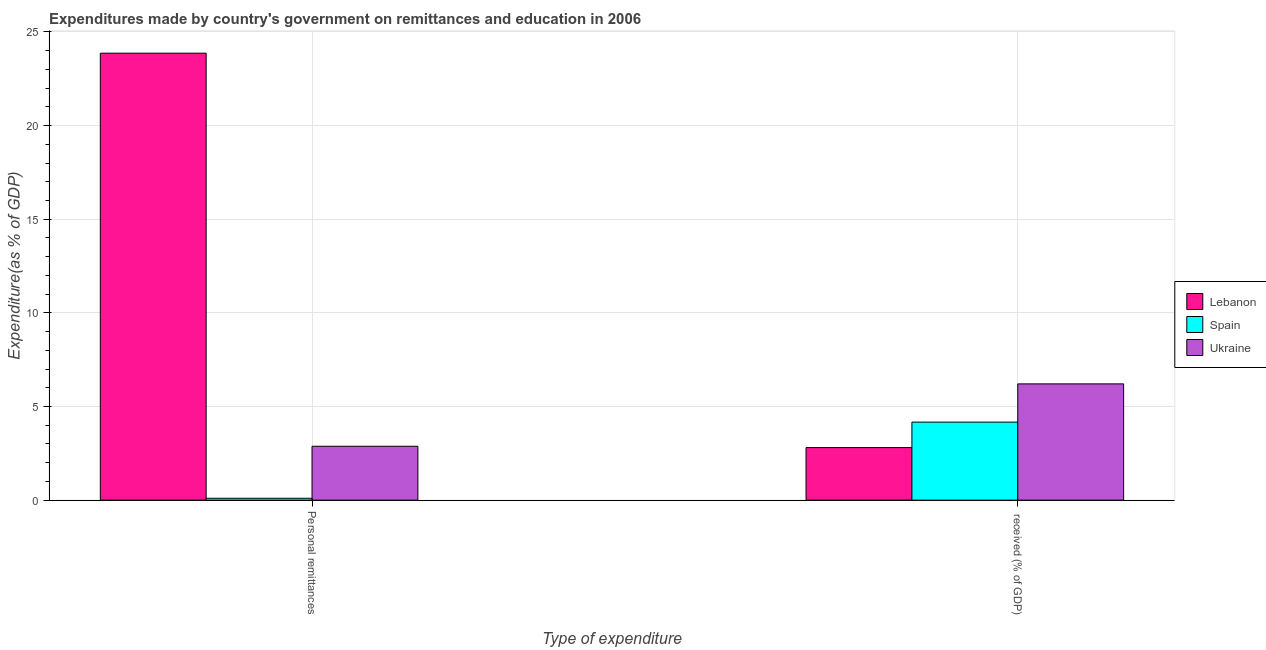How many different coloured bars are there?
Offer a very short reply. 3. How many groups of bars are there?
Offer a terse response. 2. Are the number of bars per tick equal to the number of legend labels?
Your response must be concise. Yes. Are the number of bars on each tick of the X-axis equal?
Give a very brief answer. Yes. How many bars are there on the 2nd tick from the right?
Provide a short and direct response. 3. What is the label of the 1st group of bars from the left?
Provide a short and direct response. Personal remittances. What is the expenditure in education in Ukraine?
Provide a succinct answer. 6.21. Across all countries, what is the maximum expenditure in education?
Offer a very short reply. 6.21. Across all countries, what is the minimum expenditure in education?
Make the answer very short. 2.81. In which country was the expenditure in education maximum?
Make the answer very short. Ukraine. In which country was the expenditure in education minimum?
Offer a very short reply. Lebanon. What is the total expenditure in education in the graph?
Ensure brevity in your answer.  13.18. What is the difference between the expenditure in personal remittances in Ukraine and that in Spain?
Offer a terse response. 2.78. What is the difference between the expenditure in personal remittances in Ukraine and the expenditure in education in Lebanon?
Provide a succinct answer. 0.07. What is the average expenditure in personal remittances per country?
Provide a succinct answer. 8.95. What is the difference between the expenditure in personal remittances and expenditure in education in Lebanon?
Your response must be concise. 21.06. In how many countries, is the expenditure in personal remittances greater than 18 %?
Your response must be concise. 1. What is the ratio of the expenditure in personal remittances in Ukraine to that in Spain?
Your response must be concise. 28.42. Is the expenditure in education in Ukraine less than that in Spain?
Give a very brief answer. No. What does the 3rd bar from the left in  received (% of GDP) represents?
Give a very brief answer. Ukraine. Are all the bars in the graph horizontal?
Your answer should be compact. No. Are the values on the major ticks of Y-axis written in scientific E-notation?
Your answer should be compact. No. Does the graph contain grids?
Your answer should be very brief. Yes. Where does the legend appear in the graph?
Your answer should be very brief. Center right. What is the title of the graph?
Your response must be concise. Expenditures made by country's government on remittances and education in 2006. Does "Korea (Republic)" appear as one of the legend labels in the graph?
Your answer should be compact. No. What is the label or title of the X-axis?
Ensure brevity in your answer.  Type of expenditure. What is the label or title of the Y-axis?
Your answer should be compact. Expenditure(as % of GDP). What is the Expenditure(as % of GDP) of Lebanon in Personal remittances?
Your response must be concise. 23.87. What is the Expenditure(as % of GDP) of Spain in Personal remittances?
Give a very brief answer. 0.1. What is the Expenditure(as % of GDP) of Ukraine in Personal remittances?
Make the answer very short. 2.88. What is the Expenditure(as % of GDP) of Lebanon in  received (% of GDP)?
Offer a terse response. 2.81. What is the Expenditure(as % of GDP) of Spain in  received (% of GDP)?
Your response must be concise. 4.17. What is the Expenditure(as % of GDP) in Ukraine in  received (% of GDP)?
Ensure brevity in your answer.  6.21. Across all Type of expenditure, what is the maximum Expenditure(as % of GDP) in Lebanon?
Your answer should be compact. 23.87. Across all Type of expenditure, what is the maximum Expenditure(as % of GDP) of Spain?
Ensure brevity in your answer.  4.17. Across all Type of expenditure, what is the maximum Expenditure(as % of GDP) in Ukraine?
Offer a very short reply. 6.21. Across all Type of expenditure, what is the minimum Expenditure(as % of GDP) in Lebanon?
Keep it short and to the point. 2.81. Across all Type of expenditure, what is the minimum Expenditure(as % of GDP) in Spain?
Provide a succinct answer. 0.1. Across all Type of expenditure, what is the minimum Expenditure(as % of GDP) of Ukraine?
Your answer should be compact. 2.88. What is the total Expenditure(as % of GDP) of Lebanon in the graph?
Ensure brevity in your answer.  26.68. What is the total Expenditure(as % of GDP) in Spain in the graph?
Offer a terse response. 4.27. What is the total Expenditure(as % of GDP) in Ukraine in the graph?
Your answer should be compact. 9.09. What is the difference between the Expenditure(as % of GDP) in Lebanon in Personal remittances and that in  received (% of GDP)?
Keep it short and to the point. 21.06. What is the difference between the Expenditure(as % of GDP) of Spain in Personal remittances and that in  received (% of GDP)?
Provide a short and direct response. -4.07. What is the difference between the Expenditure(as % of GDP) of Ukraine in Personal remittances and that in  received (% of GDP)?
Your answer should be very brief. -3.33. What is the difference between the Expenditure(as % of GDP) of Lebanon in Personal remittances and the Expenditure(as % of GDP) of Spain in  received (% of GDP)?
Keep it short and to the point. 19.7. What is the difference between the Expenditure(as % of GDP) in Lebanon in Personal remittances and the Expenditure(as % of GDP) in Ukraine in  received (% of GDP)?
Keep it short and to the point. 17.66. What is the difference between the Expenditure(as % of GDP) in Spain in Personal remittances and the Expenditure(as % of GDP) in Ukraine in  received (% of GDP)?
Your answer should be very brief. -6.11. What is the average Expenditure(as % of GDP) in Lebanon per Type of expenditure?
Give a very brief answer. 13.34. What is the average Expenditure(as % of GDP) in Spain per Type of expenditure?
Ensure brevity in your answer.  2.13. What is the average Expenditure(as % of GDP) in Ukraine per Type of expenditure?
Offer a very short reply. 4.54. What is the difference between the Expenditure(as % of GDP) of Lebanon and Expenditure(as % of GDP) of Spain in Personal remittances?
Offer a terse response. 23.77. What is the difference between the Expenditure(as % of GDP) in Lebanon and Expenditure(as % of GDP) in Ukraine in Personal remittances?
Make the answer very short. 20.99. What is the difference between the Expenditure(as % of GDP) of Spain and Expenditure(as % of GDP) of Ukraine in Personal remittances?
Your answer should be compact. -2.78. What is the difference between the Expenditure(as % of GDP) of Lebanon and Expenditure(as % of GDP) of Spain in  received (% of GDP)?
Ensure brevity in your answer.  -1.36. What is the difference between the Expenditure(as % of GDP) in Lebanon and Expenditure(as % of GDP) in Ukraine in  received (% of GDP)?
Your answer should be compact. -3.4. What is the difference between the Expenditure(as % of GDP) of Spain and Expenditure(as % of GDP) of Ukraine in  received (% of GDP)?
Give a very brief answer. -2.04. What is the ratio of the Expenditure(as % of GDP) in Lebanon in Personal remittances to that in  received (% of GDP)?
Your answer should be compact. 8.5. What is the ratio of the Expenditure(as % of GDP) of Spain in Personal remittances to that in  received (% of GDP)?
Keep it short and to the point. 0.02. What is the ratio of the Expenditure(as % of GDP) of Ukraine in Personal remittances to that in  received (% of GDP)?
Ensure brevity in your answer.  0.46. What is the difference between the highest and the second highest Expenditure(as % of GDP) of Lebanon?
Your answer should be compact. 21.06. What is the difference between the highest and the second highest Expenditure(as % of GDP) in Spain?
Your answer should be compact. 4.07. What is the difference between the highest and the second highest Expenditure(as % of GDP) of Ukraine?
Your answer should be compact. 3.33. What is the difference between the highest and the lowest Expenditure(as % of GDP) of Lebanon?
Keep it short and to the point. 21.06. What is the difference between the highest and the lowest Expenditure(as % of GDP) of Spain?
Provide a succinct answer. 4.07. What is the difference between the highest and the lowest Expenditure(as % of GDP) of Ukraine?
Your answer should be compact. 3.33. 